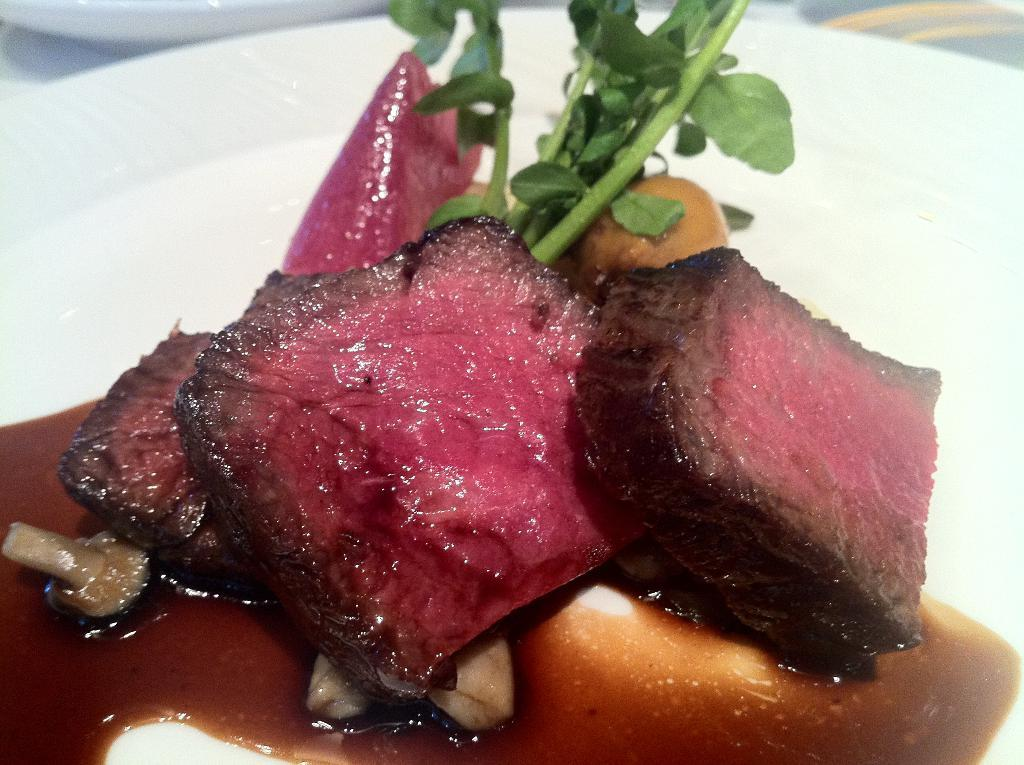What type of food can be seen in the image? There is food in the image that contains meat, mushrooms, and leaves. How is the food presented in the image? The food is in a plate. How many apples are in the crate next to the food in the image? There is no crate or apples present in the image. What time is displayed on the clock in the image? There is no clock present in the image. 